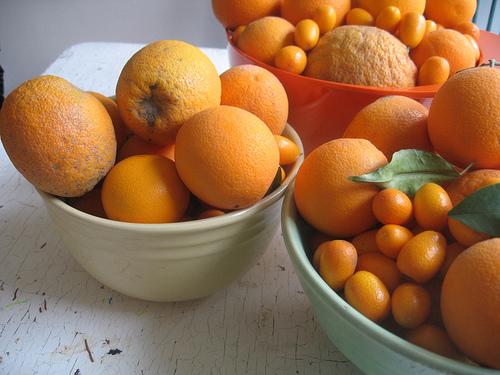<image>What items in the bowls are inedible? I don't know what items in the bowls are inedible. It could be leaves, fruits or none. What different kind of fruits is here? I am not sure what fruits are here. It could be oranges and kumquats, oranges and nectarines, or oranges and tomatoes. What items in the bowls are inedible? There are some inedible items in the bowls, such as leaves. What different kind of fruits is here? I am not sure which different kind of fruits are there. It can be seen oranges and kumquats. 